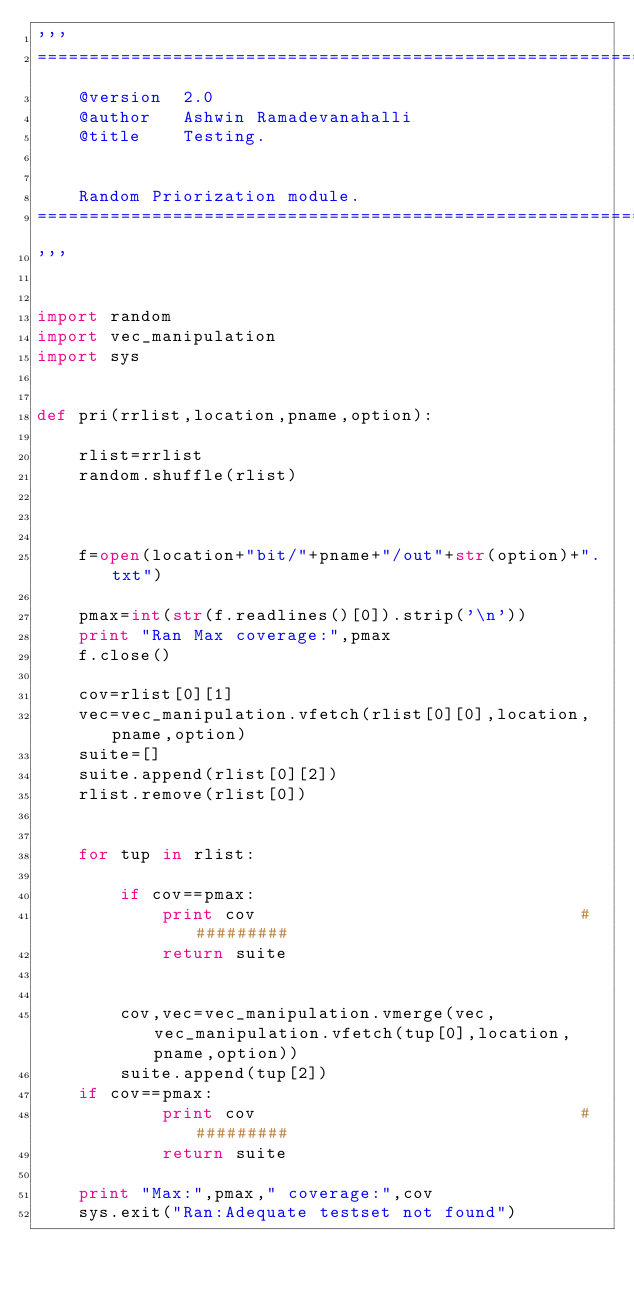Convert code to text. <code><loc_0><loc_0><loc_500><loc_500><_Python_>'''  
=================================================================
	@version  2.0
	@author   Ashwin Ramadevanahalli
	@title    Testing.


	Random Priorization module.
=================================================================
'''


import random
import vec_manipulation
import sys


def pri(rrlist,location,pname,option):
	
	rlist=rrlist
	random.shuffle(rlist)
	


	f=open(location+"bit/"+pname+"/out"+str(option)+".txt")
	
	pmax=int(str(f.readlines()[0]).strip('\n'))
	print "Ran Max coverage:",pmax
	f.close()
	
	cov=rlist[0][1]
	vec=vec_manipulation.vfetch(rlist[0][0],location,pname,option)
	suite=[]
	suite.append(rlist[0][2])
	rlist.remove(rlist[0])


	for tup in rlist:
		
		if cov==pmax:
			print cov								##########
			return suite

		
		cov,vec=vec_manipulation.vmerge(vec,vec_manipulation.vfetch(tup[0],location,pname,option))
		suite.append(tup[2])
	if cov==pmax:
			print cov								##########
			return suite
	
	print "Max:",pmax," coverage:",cov
	sys.exit("Ran:Adequate testset not found")




</code> 